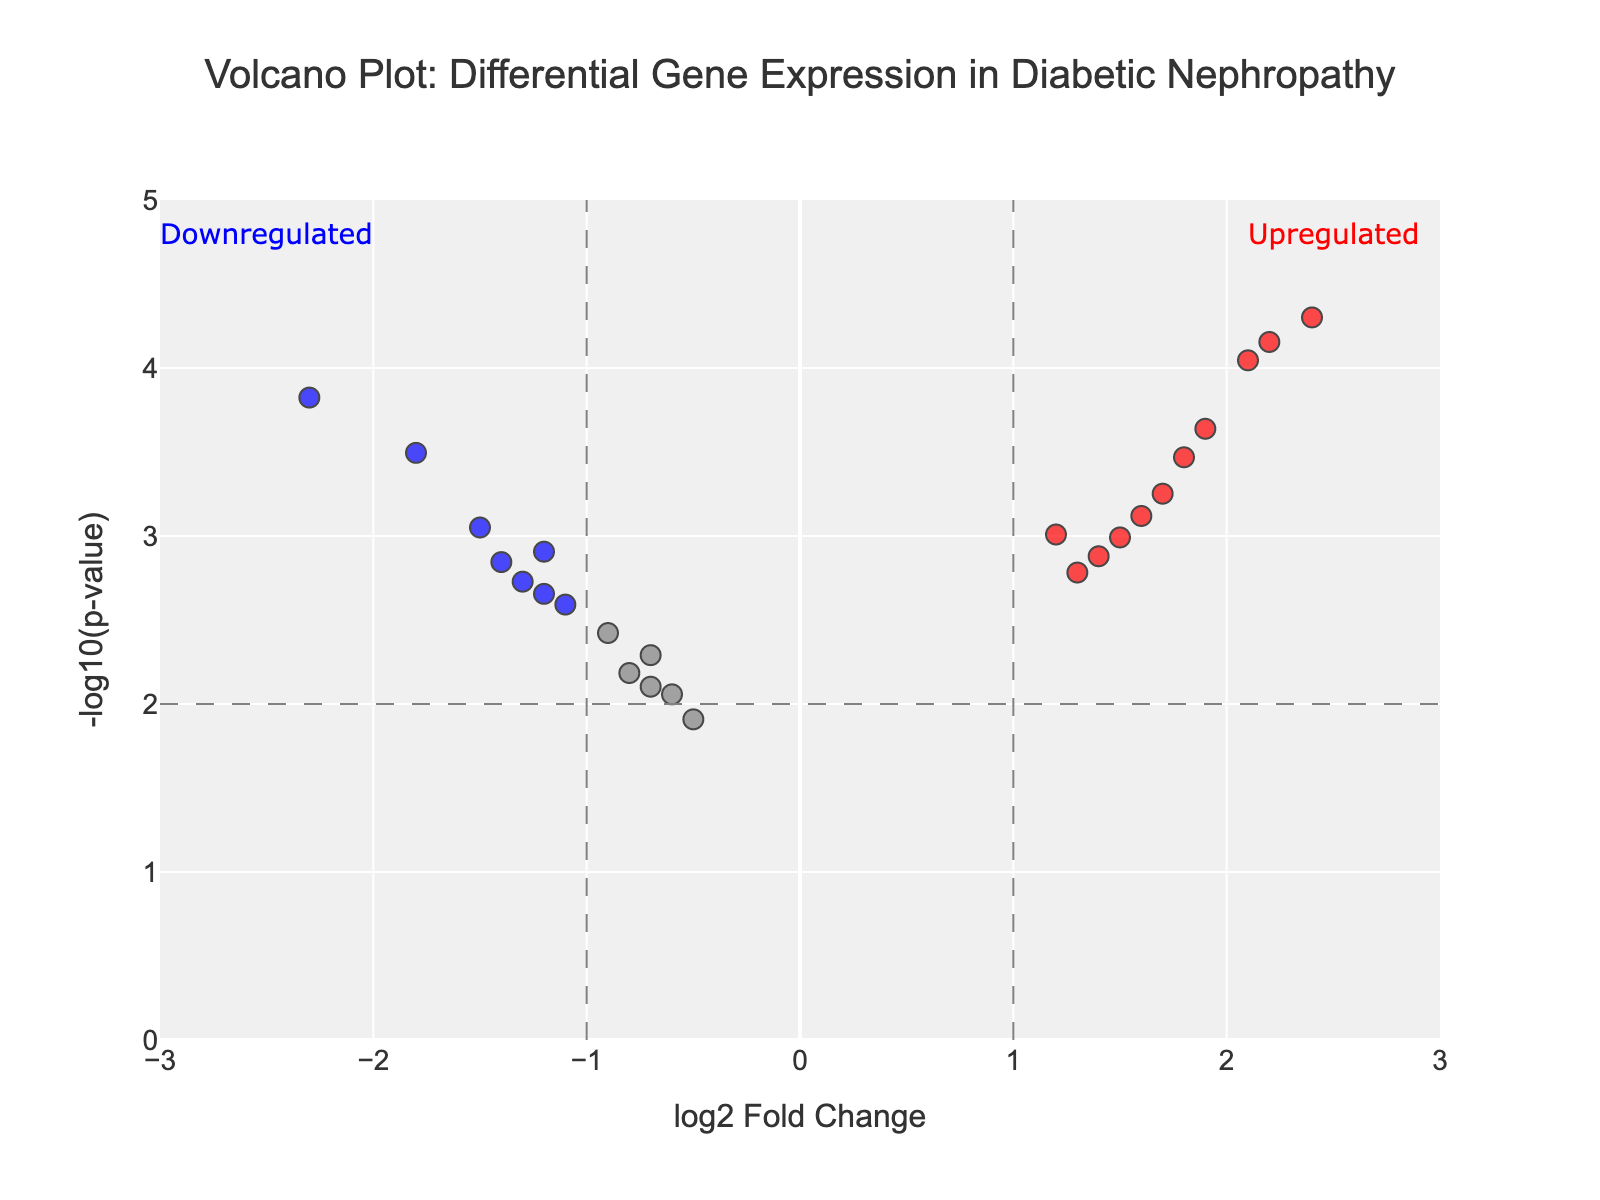How many genes are significantly upregulated in the dataset? To determine the number of significantly upregulated genes, look for genes with a log2 fold change (log2FC) greater than 1 and a p-value less than 0.01. These are colored red in the plot.
Answer: 7 Which gene has the highest -log10(p-value)? To find the gene with the highest -log10(p-value), identify the gene with the smallest p-value since -log10(p-value) is inversely related to the p-value. The gene is indicated in the plot at the highest position on the Y-axis.
Answer: NGAL What is the range of the x-axis in the plot? The x-axis range is usually specified in the plot definition or observable from the chart, showing the limits of log2 fold change values.
Answer: -3 to 3 Compare the log2 fold change and -log10(p-value) for TGF-β1 and CTGF. Locate TGF-β1 and CTGF on the plot and read their log2FC and -log10(p), respectively: TGF-β1 has log2FC of 2.1 and p-value of 0.00009, CTGF has log2FC of 1.9 and p-value of 0.00023. Therefore, -log10(p) for TGF-β1 is approximately 4.05 and for CTGF is approximately 3.64.
Answer: TGF-β1: (2.1, 4.05), CTGF: (1.9, 3.64) Are there more upregulated or downregulated genes that are significant? Count the number of genes colored red (upregulated, log2FC > 1) and blue (downregulated, log2FC < -1) to determine which category has more significant genes.
Answer: More upregulated What is the log2 fold change threshold for significance in this plot? The log2 fold change threshold for significance is indicated by the vertical dashed lines on the plot. These lines indicate the position where log2FC equals +/- the threshold.
Answer: 1 Which gene is closest to the log2 fold change threshold but is not considered significant? Identify genes near the vertical dashed lines (log2FC = +/- 1) that do not meet the p-value threshold for significance. The closest gene is the one near these lines but color-coded in grey (not significant).
Answer: CD2AP List all the significant downregulated genes. Refer to the plot and list the genes colored blue (significantly downregulated with log2FC < -1 and p-value < 0.01).
Answer: NPHS1, NPHS2, COL4A4 What does the color grey represent in the plot? The legend or color description specifies that grey points represent genes that are not significantly differentially expressed based on both log2FC and p-value thresholds.
Answer: Non-significant genes How does the color coding help in interpreting the plot? The color coding differentiates between upregulated (red), downregulated (blue), and non-significant (grey) genes, allowing for quick visual categorization based on the chosen thresholds.
Answer: Categorizes significance 